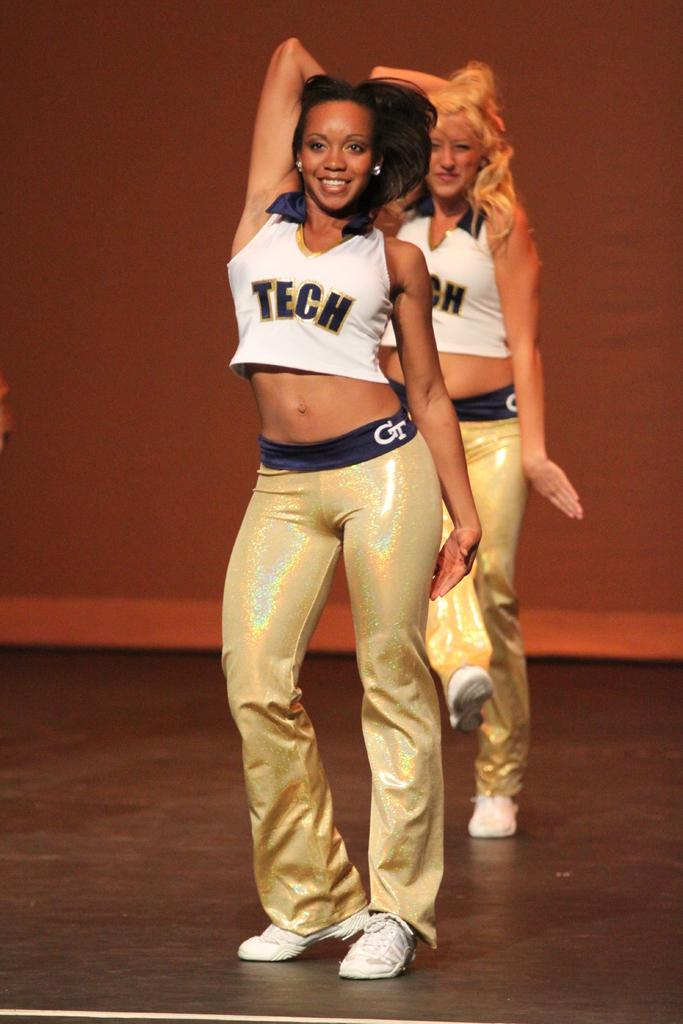<image>
Create a compact narrative representing the image presented. Two cheerleaders wearing Tech uniforms on a stage. 